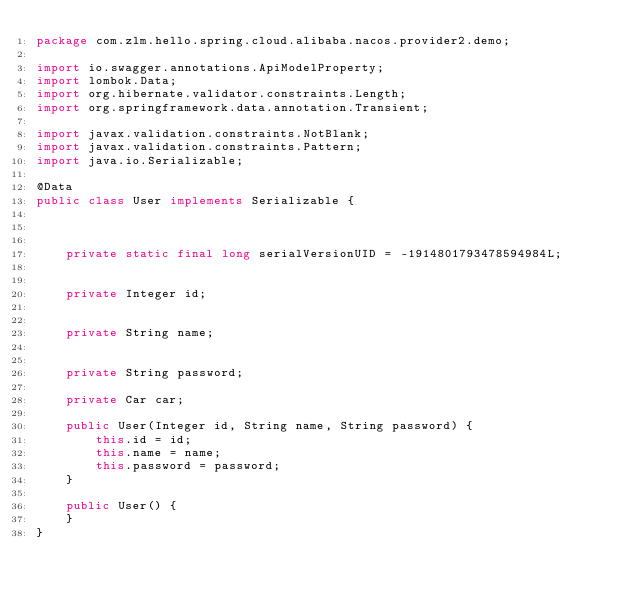<code> <loc_0><loc_0><loc_500><loc_500><_Java_>package com.zlm.hello.spring.cloud.alibaba.nacos.provider2.demo;

import io.swagger.annotations.ApiModelProperty;
import lombok.Data;
import org.hibernate.validator.constraints.Length;
import org.springframework.data.annotation.Transient;

import javax.validation.constraints.NotBlank;
import javax.validation.constraints.Pattern;
import java.io.Serializable;

@Data
public class User implements Serializable {



    private static final long serialVersionUID = -1914801793478594984L;


    private Integer id;


    private String name;


    private String password;

    private Car car;

    public User(Integer id, String name, String password) {
        this.id = id;
        this.name = name;
        this.password = password;
    }

    public User() {
    }
}
</code> 